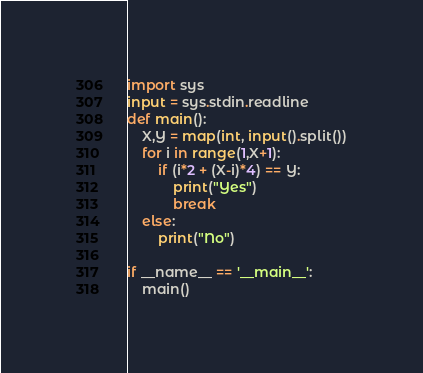Convert code to text. <code><loc_0><loc_0><loc_500><loc_500><_Python_>import sys
input = sys.stdin.readline
def main():
    X,Y = map(int, input().split())
    for i in range(1,X+1):
        if (i*2 + (X-i)*4) == Y:
            print("Yes")
            break
    else:
        print("No")

if __name__ == '__main__':
    main()</code> 